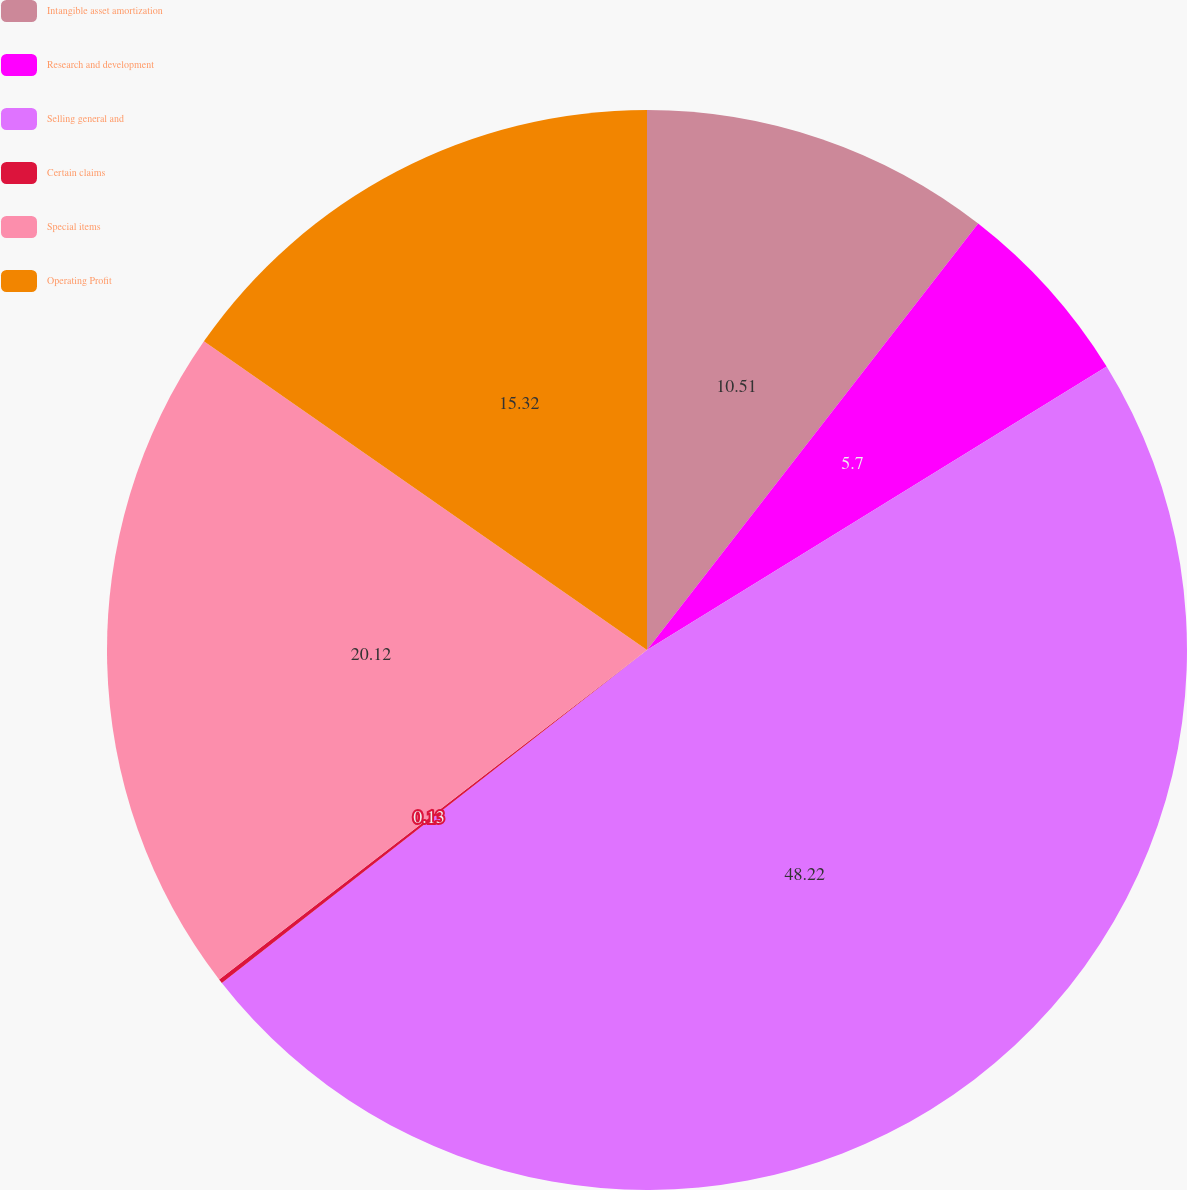Convert chart. <chart><loc_0><loc_0><loc_500><loc_500><pie_chart><fcel>Intangible asset amortization<fcel>Research and development<fcel>Selling general and<fcel>Certain claims<fcel>Special items<fcel>Operating Profit<nl><fcel>10.51%<fcel>5.7%<fcel>48.23%<fcel>0.13%<fcel>20.13%<fcel>15.32%<nl></chart> 